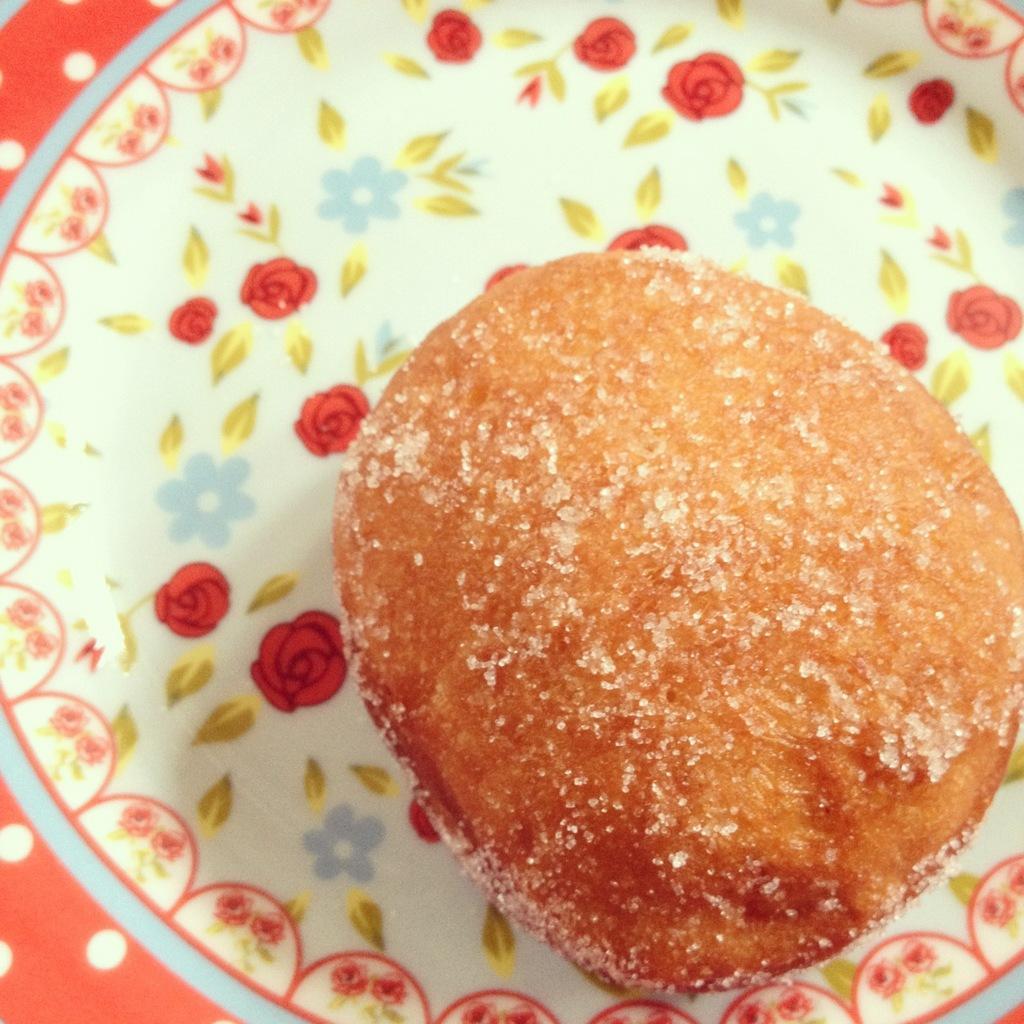Could you give a brief overview of what you see in this image? In this image we can see a food item on the plate, also we can see designs of flowers on the plate. 